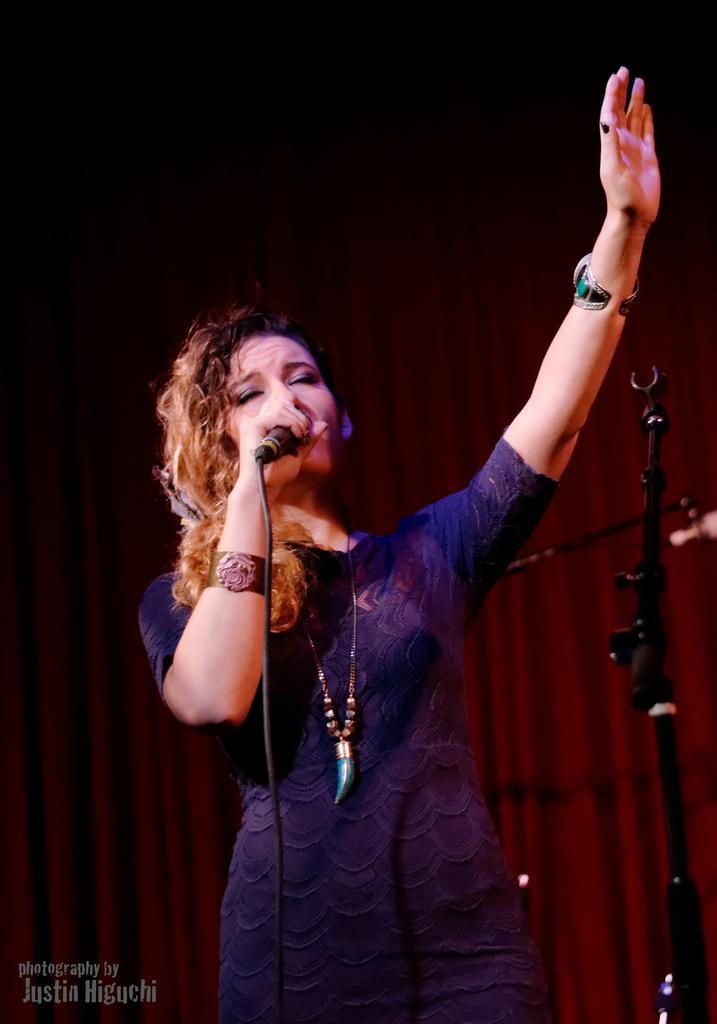In one or two sentences, can you explain what this image depicts? As we can see in the image in the front there is a woman wearing blue color dress and holding mic. Behind her there are red color curtains. 